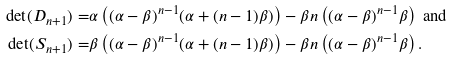Convert formula to latex. <formula><loc_0><loc_0><loc_500><loc_500>\det ( D _ { n + 1 } ) = & \alpha \left ( ( \alpha - \beta ) ^ { n - 1 } ( \alpha + ( n - 1 ) \beta ) \right ) - \beta n \left ( ( \alpha - \beta ) ^ { n - 1 } \beta \right ) \text { and } \\ \det ( S _ { n + 1 } ) = & \beta \left ( ( \alpha - \beta ) ^ { n - 1 } ( \alpha + ( n - 1 ) \beta ) \right ) - \beta n \left ( ( \alpha - \beta ) ^ { n - 1 } \beta \right ) .</formula> 